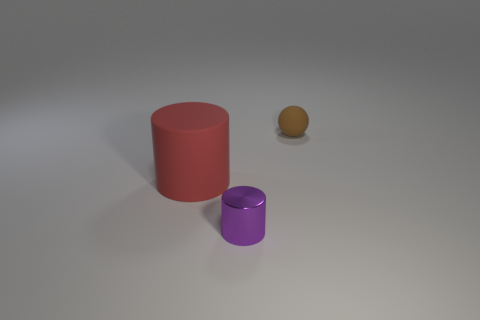Is there anything else that has the same material as the tiny cylinder?
Your response must be concise. No. Is the number of shiny objects in front of the red cylinder the same as the number of red matte cylinders in front of the brown sphere?
Your answer should be compact. Yes. What number of small things are the same material as the large red thing?
Give a very brief answer. 1. What is the size of the rubber object that is in front of the tiny object that is behind the large thing?
Your answer should be very brief. Large. There is a small object in front of the matte cylinder; does it have the same shape as the small object behind the big red rubber cylinder?
Offer a very short reply. No. Are there the same number of small purple cylinders that are to the left of the shiny cylinder and big brown metallic things?
Provide a succinct answer. Yes. What color is the rubber thing that is the same shape as the small shiny thing?
Your answer should be compact. Red. Are the tiny thing in front of the small matte ball and the big thing made of the same material?
Your answer should be compact. No. How many big objects are brown balls or purple things?
Offer a terse response. 0. What size is the brown matte thing?
Make the answer very short. Small. 